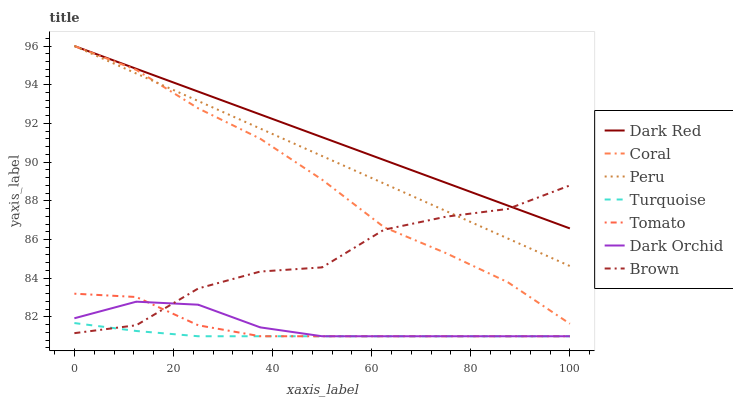Does Turquoise have the minimum area under the curve?
Answer yes or no. Yes. Does Dark Red have the maximum area under the curve?
Answer yes or no. Yes. Does Brown have the minimum area under the curve?
Answer yes or no. No. Does Brown have the maximum area under the curve?
Answer yes or no. No. Is Dark Red the smoothest?
Answer yes or no. Yes. Is Brown the roughest?
Answer yes or no. Yes. Is Turquoise the smoothest?
Answer yes or no. No. Is Turquoise the roughest?
Answer yes or no. No. Does Tomato have the lowest value?
Answer yes or no. Yes. Does Brown have the lowest value?
Answer yes or no. No. Does Peru have the highest value?
Answer yes or no. Yes. Does Brown have the highest value?
Answer yes or no. No. Is Dark Orchid less than Dark Red?
Answer yes or no. Yes. Is Peru greater than Turquoise?
Answer yes or no. Yes. Does Tomato intersect Dark Orchid?
Answer yes or no. Yes. Is Tomato less than Dark Orchid?
Answer yes or no. No. Is Tomato greater than Dark Orchid?
Answer yes or no. No. Does Dark Orchid intersect Dark Red?
Answer yes or no. No. 